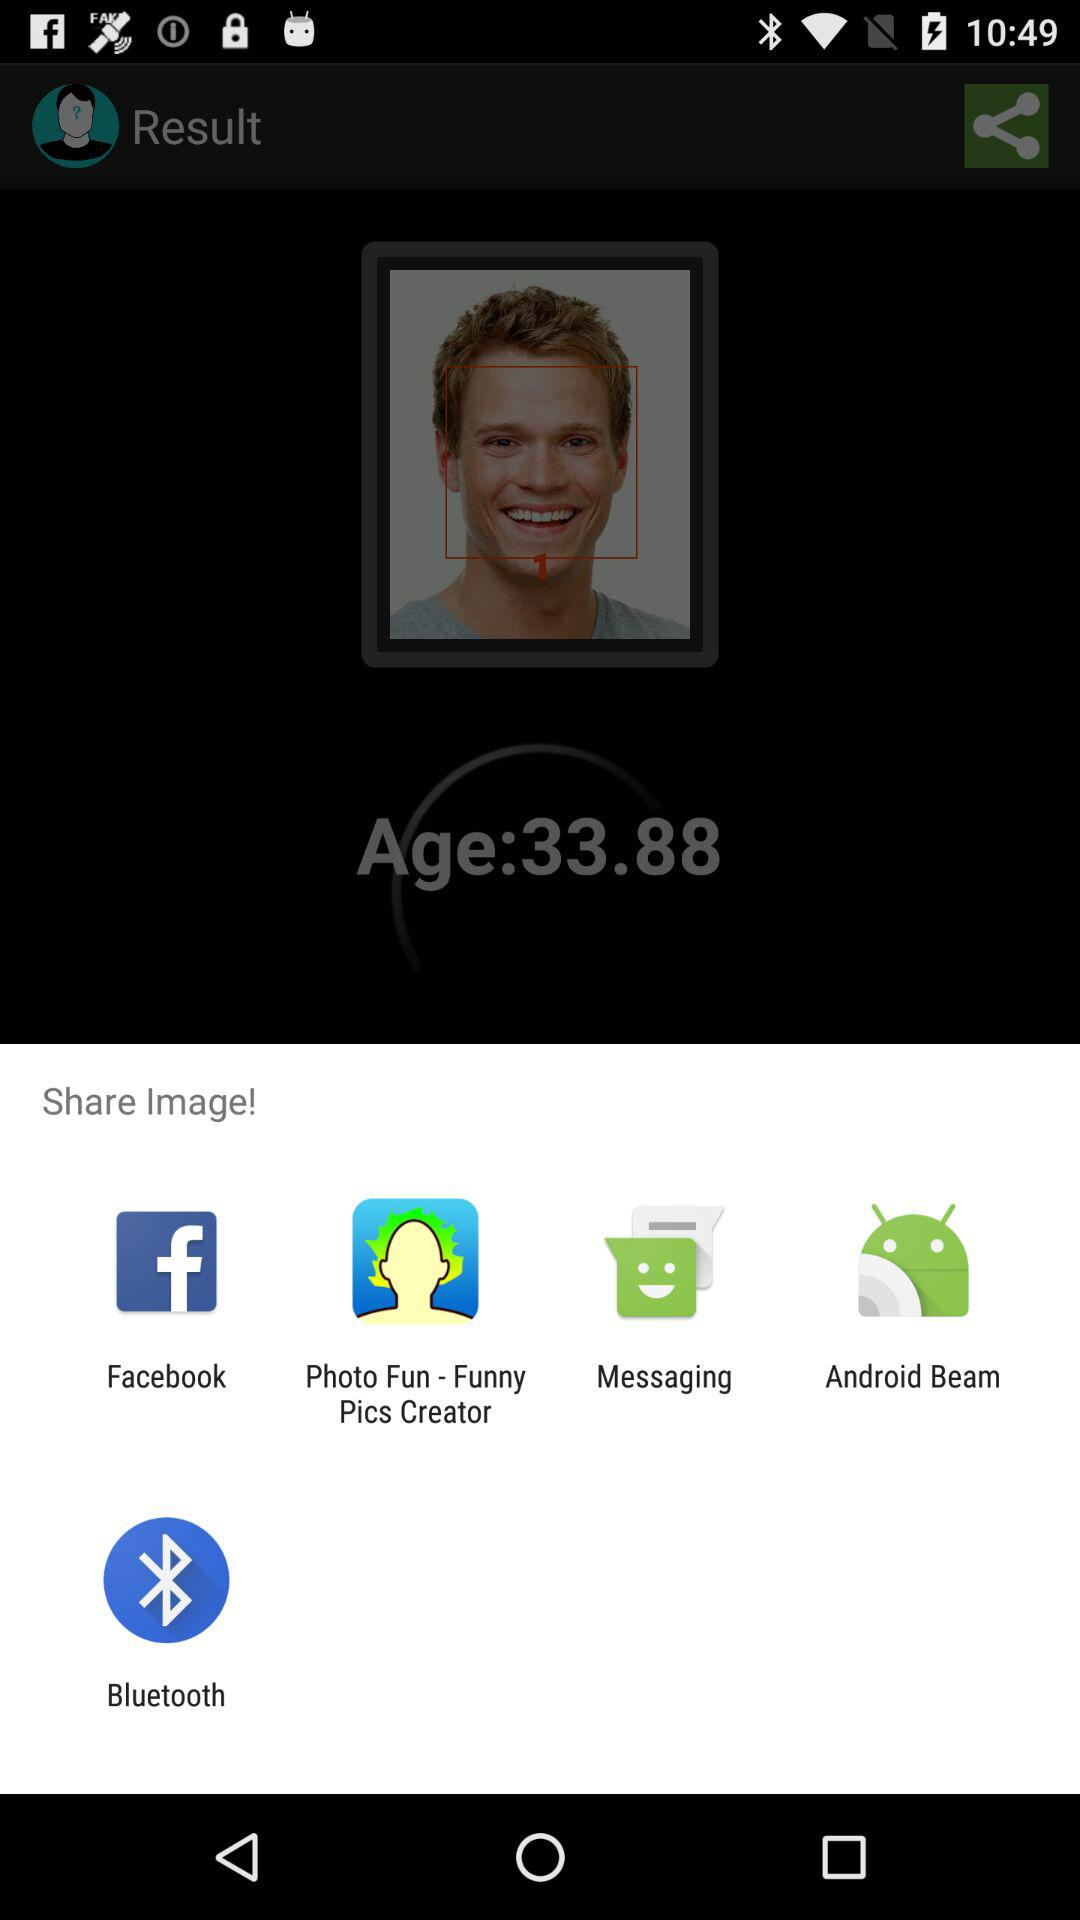What is the age of the user? The age of the user is 33.88. 